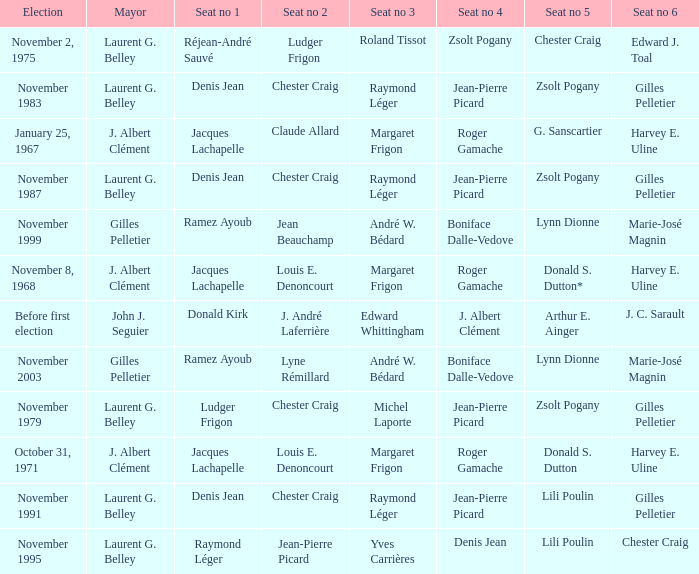Which election had seat no 1 filled by jacques lachapelle but seat no 5 was filled by g. sanscartier January 25, 1967. 